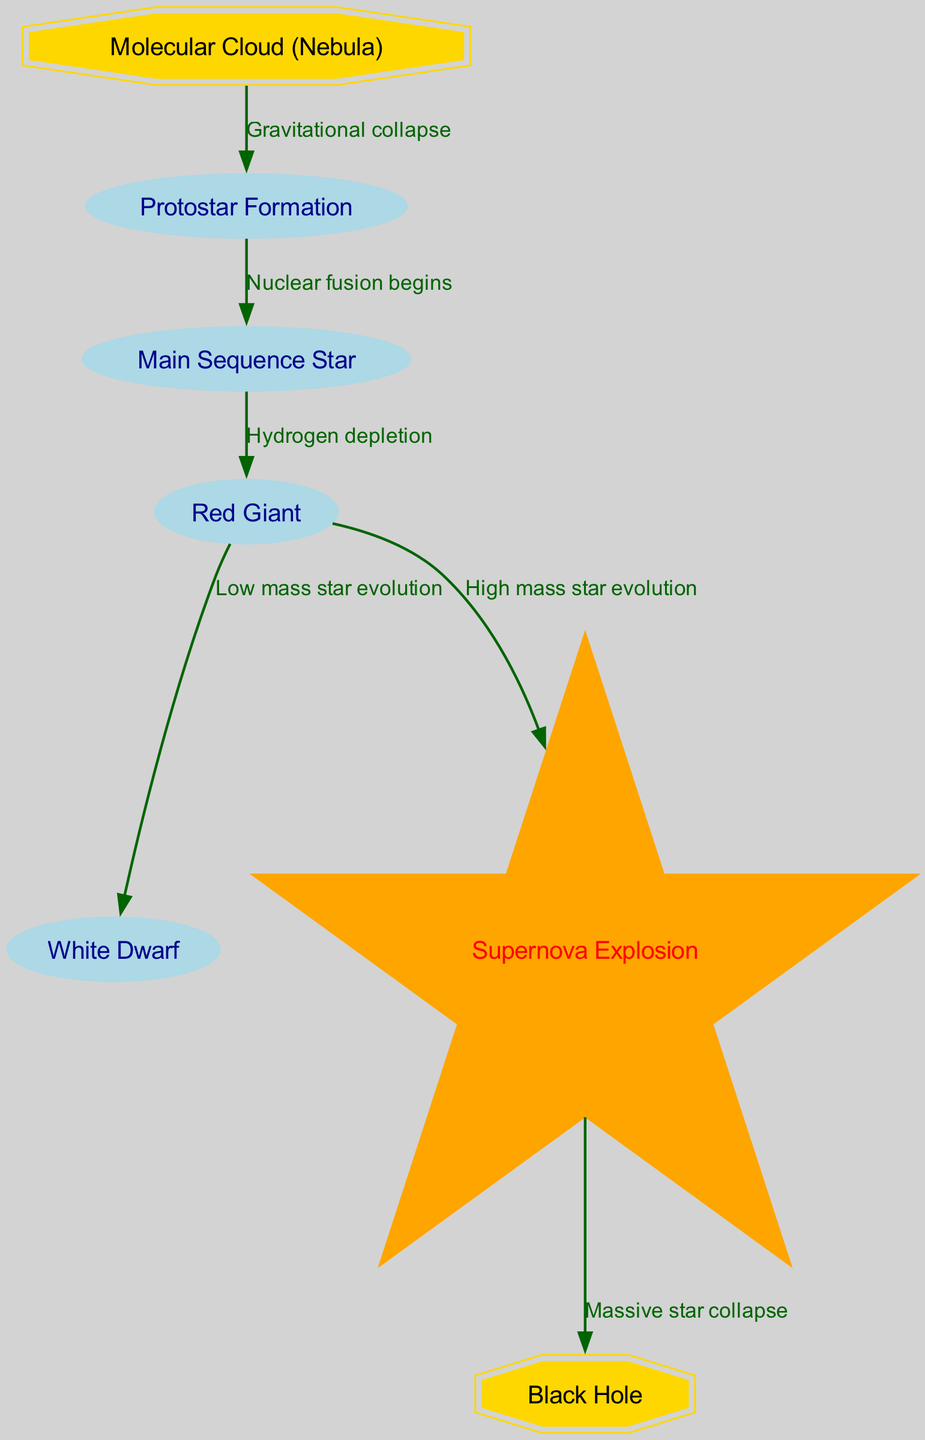What is the first stage of a star's life cycle according to the diagram? The diagram indicates that the first stage of a star's life cycle is labeled as "Molecular Cloud (Nebula)". It is the initial node in the flow of star evolution.
Answer: Molecular Cloud (Nebula) How many nodes are present in the diagram? By counting the nodes listed in the data section, there are a total of 7 unique stages in the star lifecycle, including the nebula, protostar, main sequence star, red giant, white dwarf, supernova explosion, and black hole.
Answer: 7 What process leads to the formation of a protostar from a nebula? The diagram shows a directed edge from the Molecular Cloud (Nebula) to Protostar Formation, labeled "Gravitational collapse". This indicates that gravitational collapse is the process that triggers the formation of a protostar.
Answer: Gravitational collapse What occurs between the main sequence star and red giant stages? The transition from Main Sequence Star to Red Giant occurs due to "Hydrogen depletion", which is indicated as the label on the directed edge between these two nodes.
Answer: Hydrogen depletion What happens to a massive star after a supernova event? The diagram clearly illustrates that following a Supernova Explosion, a Massive Star collapses into a Black Hole, as indicated by the directed edge labeled "Massive star collapse".
Answer: Black Hole How does low mass star evolution lead to the final stages? The Red Giant stage transitions to either a White Dwarf or a Supernova Explosion, depending on the mass of the star. For low mass stars, it evolves to a White Dwarf, as indicated by the directed edge labeled "Low mass star evolution".
Answer: White Dwarf What is the connection between the red giant stage and the two possible endings in the lifecycle? The direct connections in the diagram show two edges branching out from the Red Giant node: one leading to the White Dwarf labeled "Low mass star evolution", and the other to the Supernova Explosion labeled "High mass star evolution". This indicates that the path followed depends on the star's mass during its evolution.
Answer: Low mass star evolution and High mass star evolution 